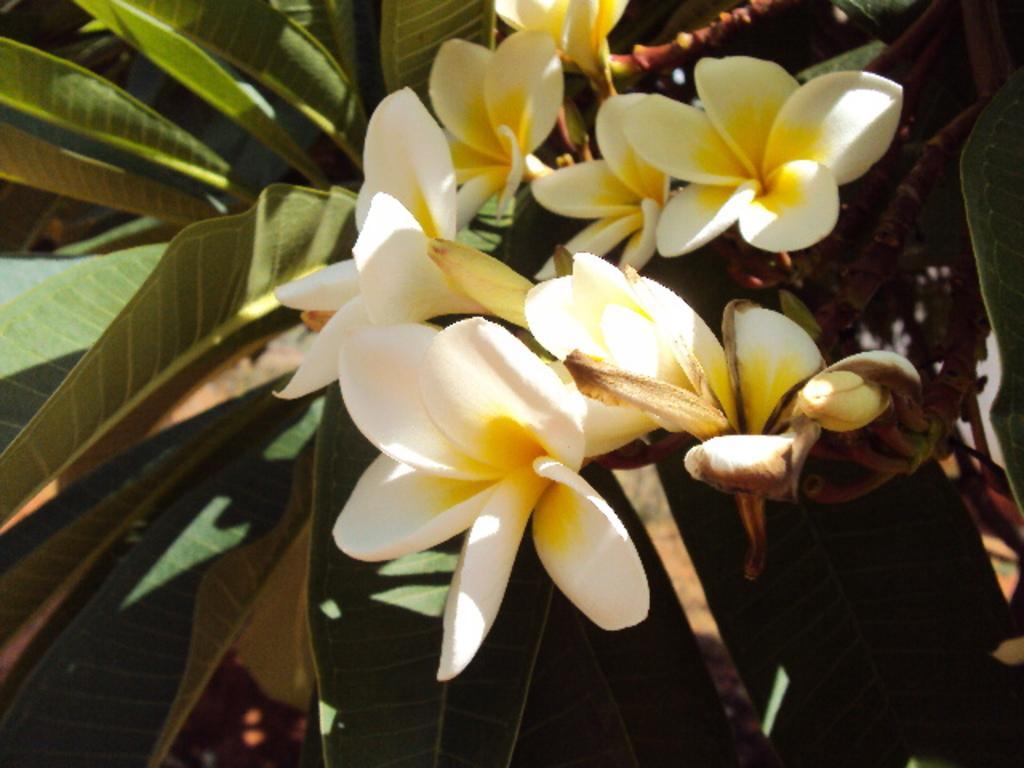Could you give a brief overview of what you see in this image? In this image there is a tree and we can see flowers. In the background there are leaves. 